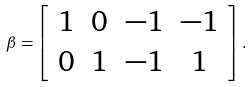<formula> <loc_0><loc_0><loc_500><loc_500>\beta = \left [ \begin{array} { c c c c } 1 & 0 & - 1 & - 1 \\ 0 & 1 & - 1 & 1 \end{array} \right ] .</formula> 